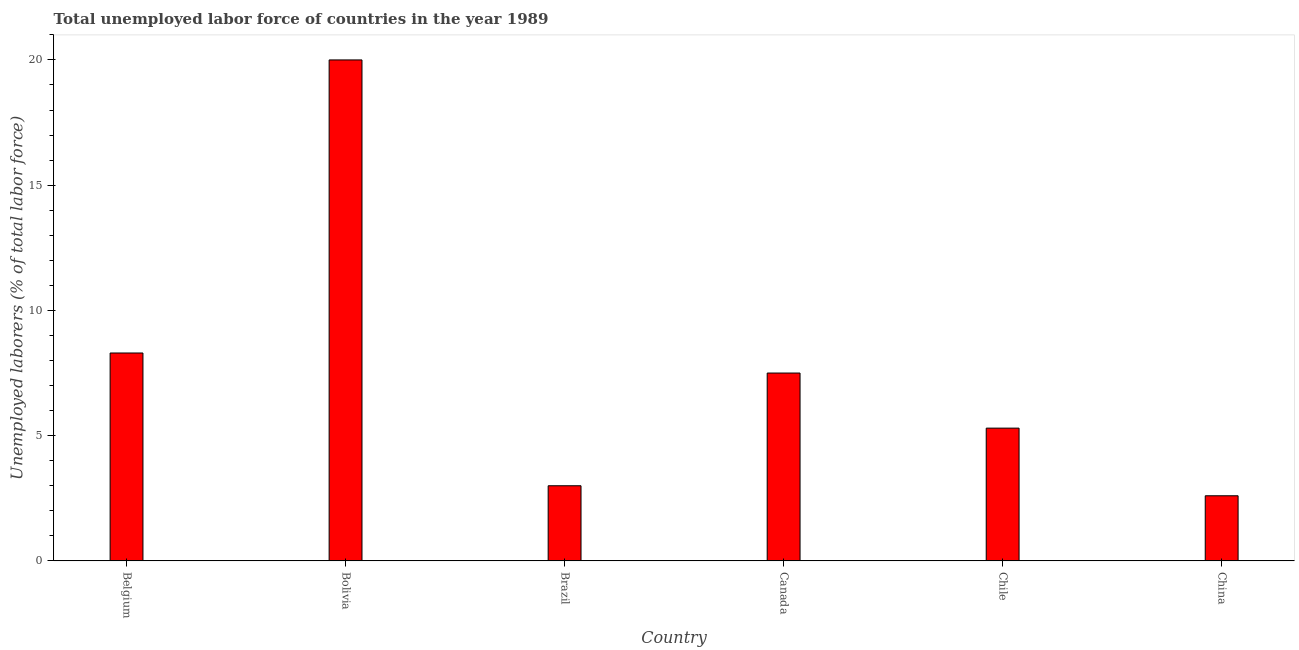Does the graph contain any zero values?
Offer a terse response. No. What is the title of the graph?
Offer a terse response. Total unemployed labor force of countries in the year 1989. What is the label or title of the Y-axis?
Your answer should be compact. Unemployed laborers (% of total labor force). What is the total unemployed labour force in Belgium?
Offer a very short reply. 8.3. Across all countries, what is the maximum total unemployed labour force?
Provide a succinct answer. 20. Across all countries, what is the minimum total unemployed labour force?
Offer a very short reply. 2.6. In which country was the total unemployed labour force maximum?
Your response must be concise. Bolivia. In which country was the total unemployed labour force minimum?
Offer a terse response. China. What is the sum of the total unemployed labour force?
Your answer should be very brief. 46.7. What is the difference between the total unemployed labour force in Canada and Chile?
Keep it short and to the point. 2.2. What is the average total unemployed labour force per country?
Keep it short and to the point. 7.78. What is the median total unemployed labour force?
Provide a short and direct response. 6.4. What is the ratio of the total unemployed labour force in Chile to that in China?
Keep it short and to the point. 2.04. Is the difference between the total unemployed labour force in Belgium and China greater than the difference between any two countries?
Your answer should be compact. No. In how many countries, is the total unemployed labour force greater than the average total unemployed labour force taken over all countries?
Offer a very short reply. 2. How many countries are there in the graph?
Offer a terse response. 6. What is the difference between two consecutive major ticks on the Y-axis?
Your answer should be compact. 5. Are the values on the major ticks of Y-axis written in scientific E-notation?
Keep it short and to the point. No. What is the Unemployed laborers (% of total labor force) of Belgium?
Provide a succinct answer. 8.3. What is the Unemployed laborers (% of total labor force) in Canada?
Your answer should be very brief. 7.5. What is the Unemployed laborers (% of total labor force) of Chile?
Keep it short and to the point. 5.3. What is the Unemployed laborers (% of total labor force) in China?
Offer a terse response. 2.6. What is the difference between the Unemployed laborers (% of total labor force) in Belgium and Chile?
Provide a succinct answer. 3. What is the difference between the Unemployed laborers (% of total labor force) in Bolivia and Brazil?
Your answer should be compact. 17. What is the difference between the Unemployed laborers (% of total labor force) in Bolivia and China?
Ensure brevity in your answer.  17.4. What is the difference between the Unemployed laborers (% of total labor force) in Brazil and Canada?
Your answer should be compact. -4.5. What is the difference between the Unemployed laborers (% of total labor force) in Brazil and China?
Your response must be concise. 0.4. What is the difference between the Unemployed laborers (% of total labor force) in Chile and China?
Offer a terse response. 2.7. What is the ratio of the Unemployed laborers (% of total labor force) in Belgium to that in Bolivia?
Make the answer very short. 0.41. What is the ratio of the Unemployed laborers (% of total labor force) in Belgium to that in Brazil?
Provide a succinct answer. 2.77. What is the ratio of the Unemployed laborers (% of total labor force) in Belgium to that in Canada?
Your response must be concise. 1.11. What is the ratio of the Unemployed laborers (% of total labor force) in Belgium to that in Chile?
Provide a short and direct response. 1.57. What is the ratio of the Unemployed laborers (% of total labor force) in Belgium to that in China?
Offer a very short reply. 3.19. What is the ratio of the Unemployed laborers (% of total labor force) in Bolivia to that in Brazil?
Your response must be concise. 6.67. What is the ratio of the Unemployed laborers (% of total labor force) in Bolivia to that in Canada?
Your answer should be very brief. 2.67. What is the ratio of the Unemployed laborers (% of total labor force) in Bolivia to that in Chile?
Your answer should be very brief. 3.77. What is the ratio of the Unemployed laborers (% of total labor force) in Bolivia to that in China?
Make the answer very short. 7.69. What is the ratio of the Unemployed laborers (% of total labor force) in Brazil to that in Chile?
Give a very brief answer. 0.57. What is the ratio of the Unemployed laborers (% of total labor force) in Brazil to that in China?
Your answer should be very brief. 1.15. What is the ratio of the Unemployed laborers (% of total labor force) in Canada to that in Chile?
Keep it short and to the point. 1.42. What is the ratio of the Unemployed laborers (% of total labor force) in Canada to that in China?
Your answer should be compact. 2.88. What is the ratio of the Unemployed laborers (% of total labor force) in Chile to that in China?
Give a very brief answer. 2.04. 